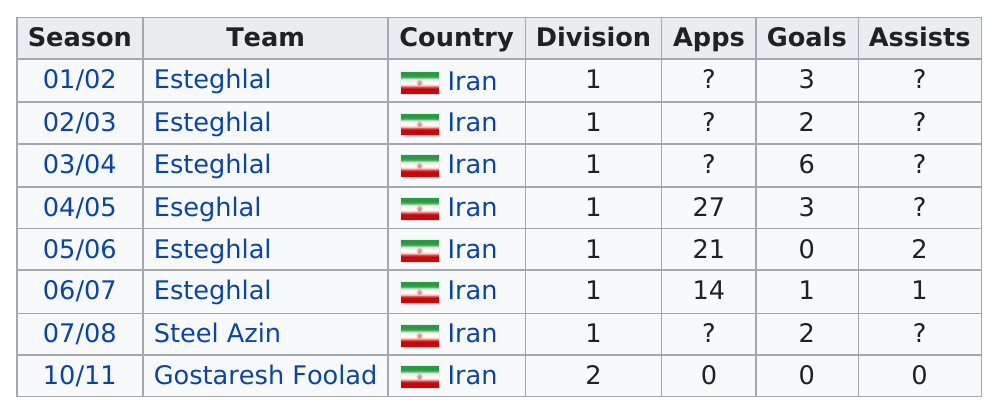Point out several critical features in this image. On September 26th, Gostaresh Foolad did not record any assists in their match against Esteghlal Khuzestan. For how many consecutive years did he score more than 2 goals? 2.. In the season of 2005-2006, there was a total of two assists. In the 2004-2005 season, a total of 27 apps were obtained. After the 2004/2005 season, there were three goals recorded. 